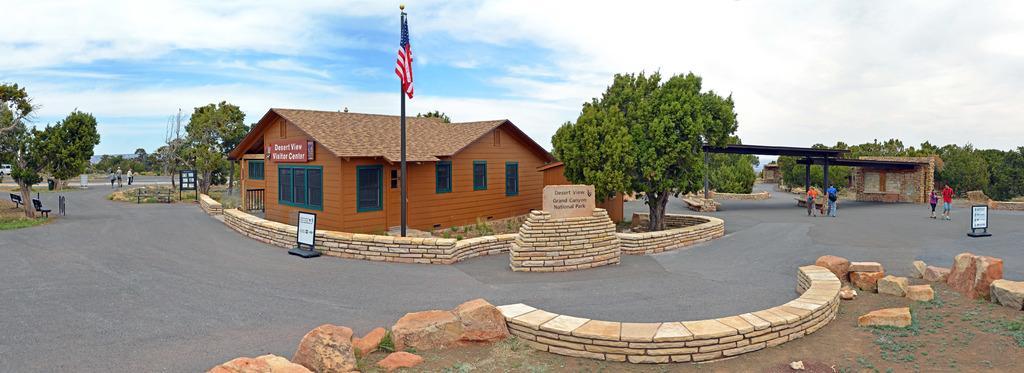In one or two sentences, can you explain what this image depicts? In this image we can see a house, trees, name boards, flag, rocks and other objects. On the right side of the image there are some person, name board, rocks, trees, shed and other objects. On the left side of the image there are some trees, chairs, road, people and other objects, At the bottom of the image there are rocks, rocky land and an object. 